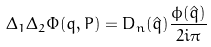Convert formula to latex. <formula><loc_0><loc_0><loc_500><loc_500>\Delta _ { 1 } \Delta _ { 2 } \Phi ( q , P ) = D _ { n } ( { \hat { q } } ) \frac { \phi ( { \hat { q } } ) } { 2 i \pi }</formula> 